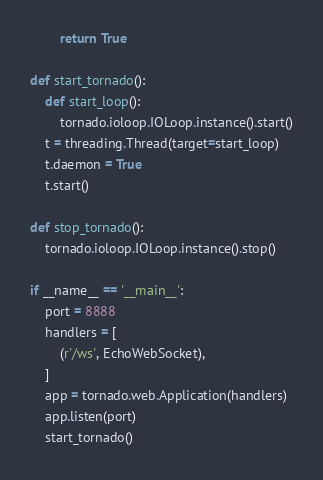Convert code to text. <code><loc_0><loc_0><loc_500><loc_500><_Python_>        return True

def start_tornado():
    def start_loop():
        tornado.ioloop.IOLoop.instance().start()
    t = threading.Thread(target=start_loop)
    t.daemon = True
    t.start()

def stop_tornado():
    tornado.ioloop.IOLoop.instance().stop()

if __name__ == '__main__':
    port = 8888
    handlers = [
        (r'/ws', EchoWebSocket),
    ]
    app = tornado.web.Application(handlers)
    app.listen(port)
    start_tornado()
</code> 